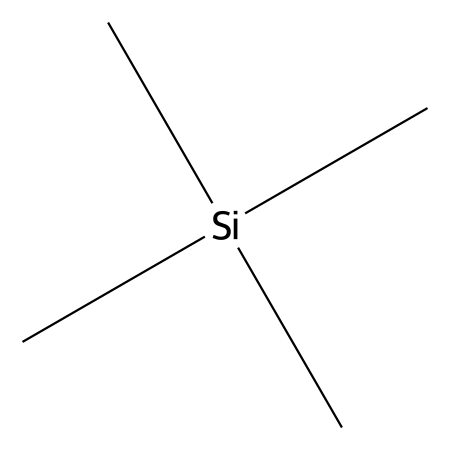What is the molecular formula of the compound? The SMILES notation provided indicates the presence of three methyl groups (C) bound to a silicon atom (Si) and one additional carbon atom. Thus, adding these together yields a molecular formula C4H12Si.
Answer: C4H12Si How many carbon atoms are in the molecule? From the SMILES representation, you can count three methyl groups and one additional carbon, giving a total of four carbon atoms in the structure.
Answer: 4 What is the hybridization of the silicon atom? The silicon atom in the structure is bonded to three methyl groups and one carbon. This indicates that it is using four orbitals to bond, which corresponds to sp3 hybridization.
Answer: sp3 What kind of structural group does this compound depict? The compound contains three methyl groups attached to a silicon atom, characterizing it as a trimethylsilyl (TMS) group, which is a common functional group in organosilicon chemistry.
Answer: trimethylsilyl What type of bonding is primarily responsible for the stability of trimethylsilyl groups? The stability of trimethylsilyl groups is mainly due to the strong covalent bonds formed between silicon and carbon, ensuring that the structure remains intact under standard conditions.
Answer: covalent How does the presence of TMS groups affect the chemical shifts in NMR spectroscopy? Trimethylsilyl groups are known to provide a reference point in NMR spectroscopy because they are highly symmetrical and produce a strong signal, which can help in pinpointing the shifts of other functional groups within the compound being analyzed.
Answer: reference point What is the expected NMR chemical shift for the methyl protons in TMS? The methyl protons in a trimethylsilyl group typically resonate around 0 ppm in NMR spectroscopy, making it an important reference standard for chemical shifts.
Answer: 0 ppm 